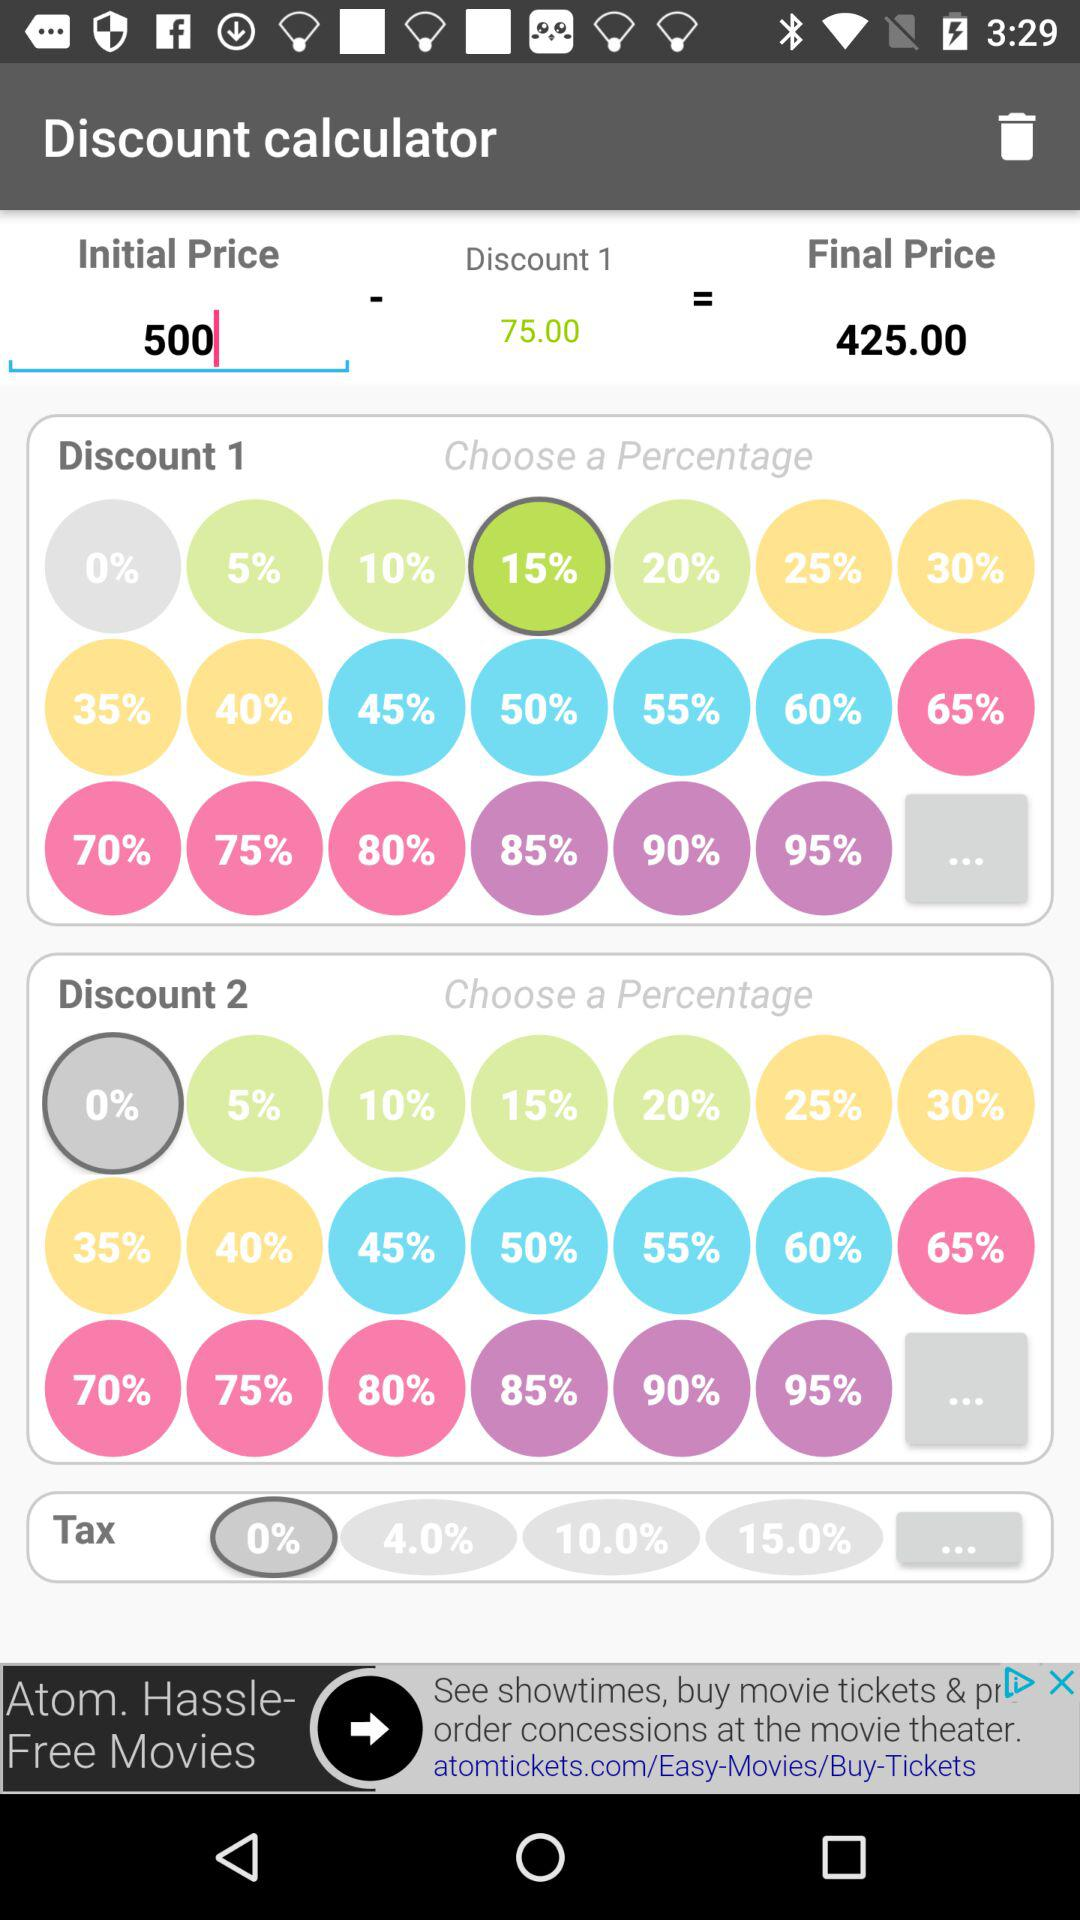What is the selected percentage of discount for discount 1? The selected percentage of discount for discount 1 is 15. 